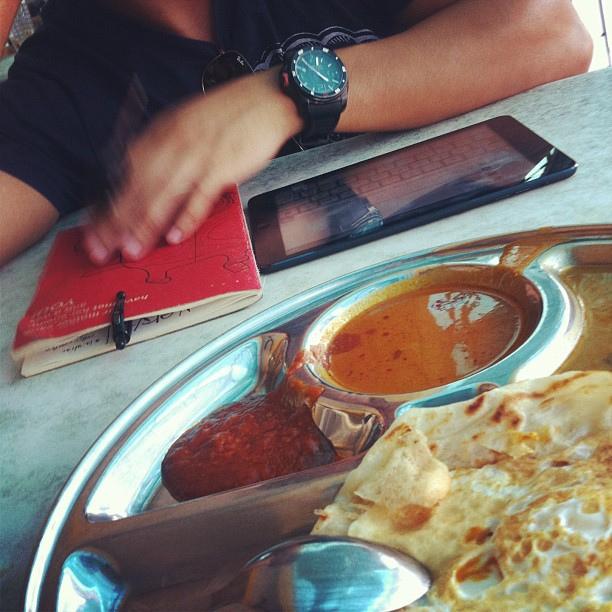Is the person wearing a watch?
Be succinct. Yes. What object do you see reflected in the tablet screen?
Keep it brief. Watch. What color is the book?
Be succinct. Red. 